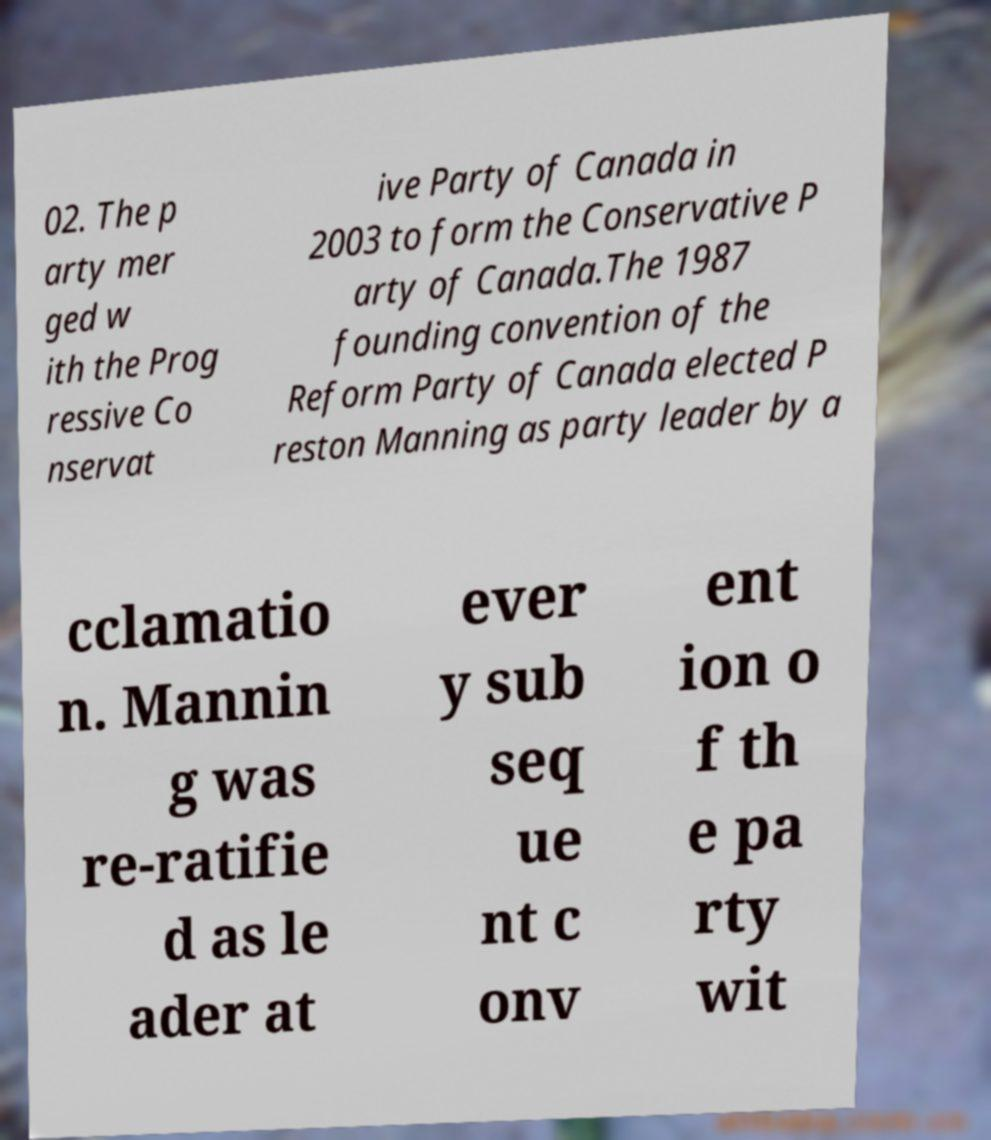Please identify and transcribe the text found in this image. 02. The p arty mer ged w ith the Prog ressive Co nservat ive Party of Canada in 2003 to form the Conservative P arty of Canada.The 1987 founding convention of the Reform Party of Canada elected P reston Manning as party leader by a cclamatio n. Mannin g was re-ratifie d as le ader at ever y sub seq ue nt c onv ent ion o f th e pa rty wit 